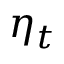<formula> <loc_0><loc_0><loc_500><loc_500>\eta _ { t }</formula> 